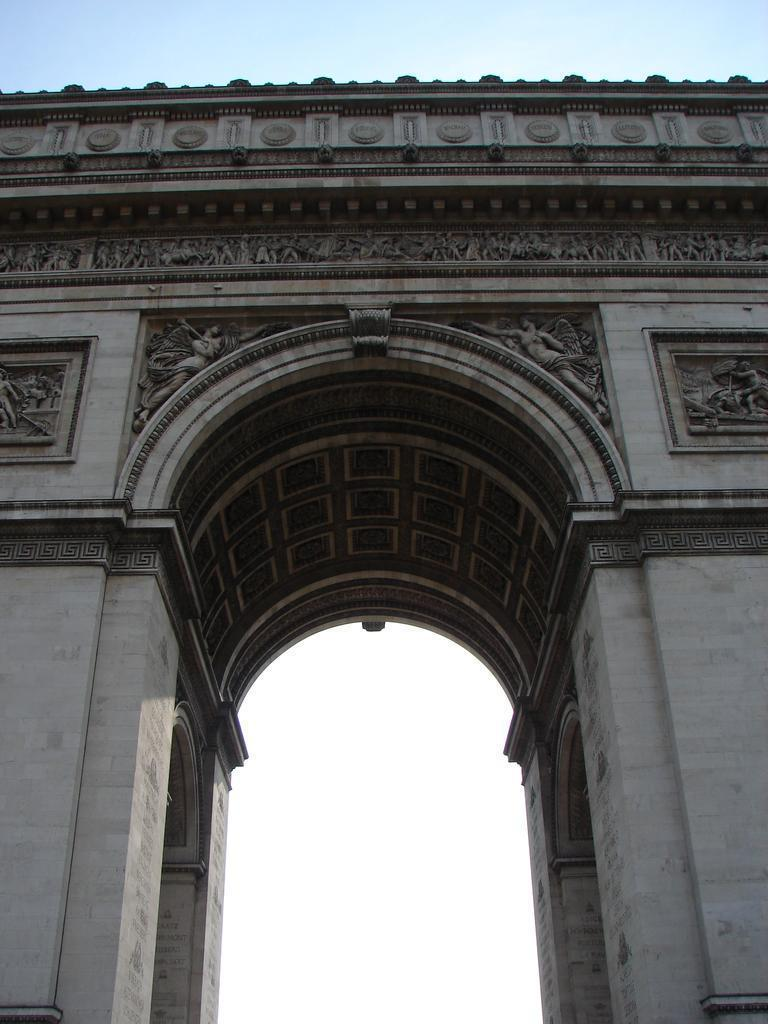What type of structure can be seen in the image? There is a wall in the image. What artistic elements are present in the image? There are sculptures in the image. What is visible at the top of the image? The sky is visible at the top of the image. Where is the throne located in the image? There is no throne present in the image. What type of animal can be seen interacting with the sculptures in the image? There are no animals present in the image; it only features a wall and sculptures. 